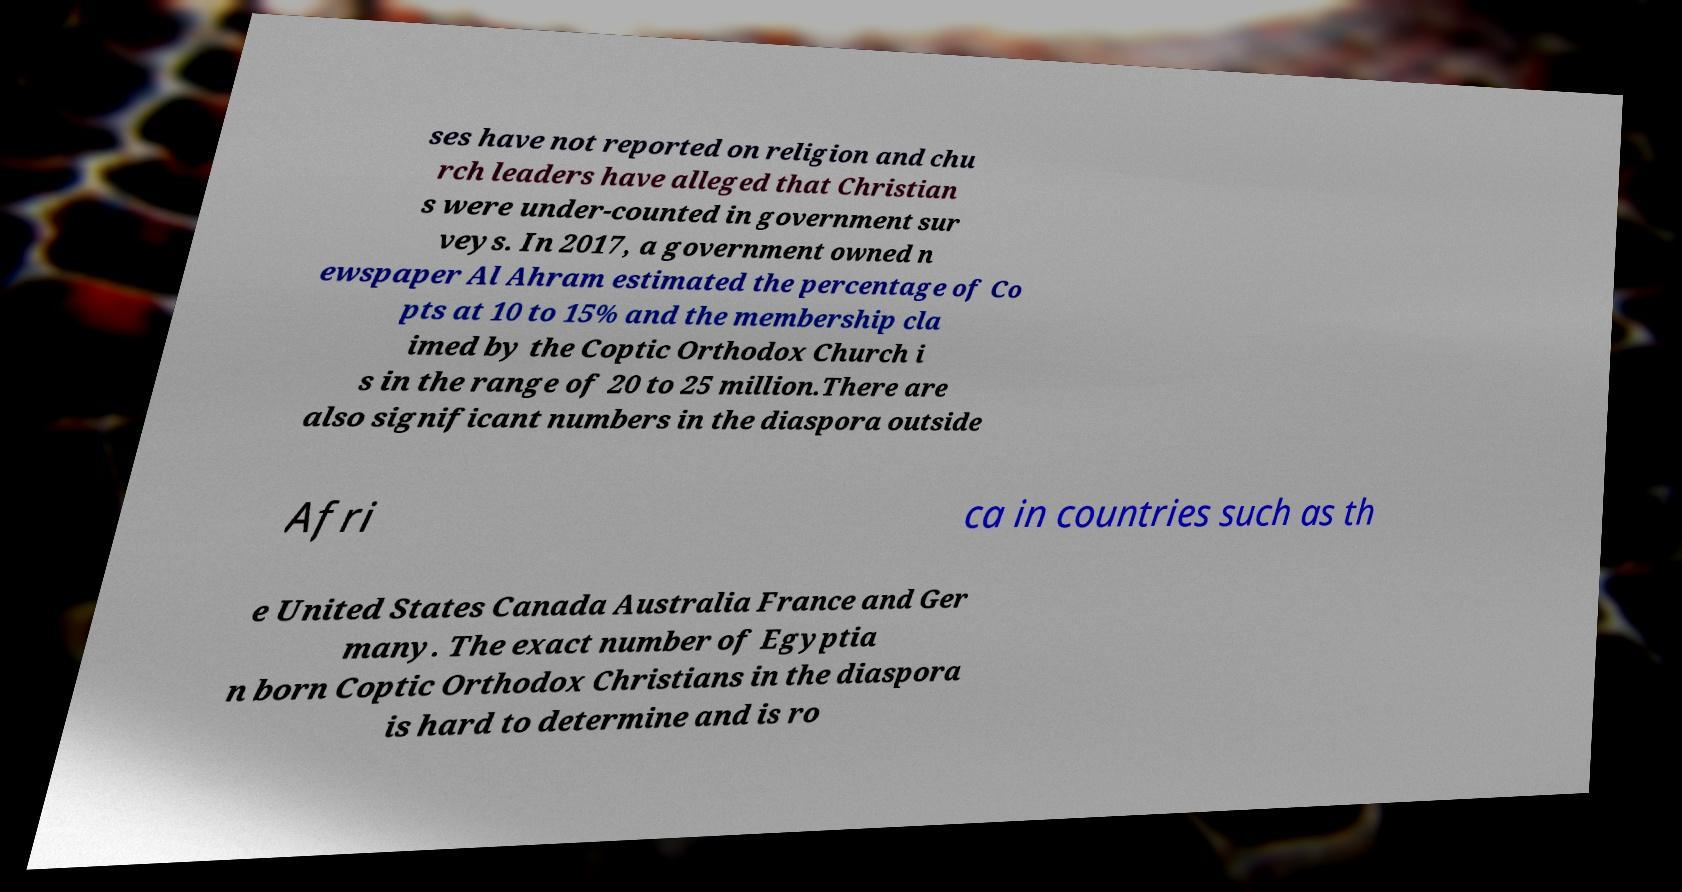Can you read and provide the text displayed in the image?This photo seems to have some interesting text. Can you extract and type it out for me? ses have not reported on religion and chu rch leaders have alleged that Christian s were under-counted in government sur veys. In 2017, a government owned n ewspaper Al Ahram estimated the percentage of Co pts at 10 to 15% and the membership cla imed by the Coptic Orthodox Church i s in the range of 20 to 25 million.There are also significant numbers in the diaspora outside Afri ca in countries such as th e United States Canada Australia France and Ger many. The exact number of Egyptia n born Coptic Orthodox Christians in the diaspora is hard to determine and is ro 